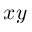<formula> <loc_0><loc_0><loc_500><loc_500>x y</formula> 